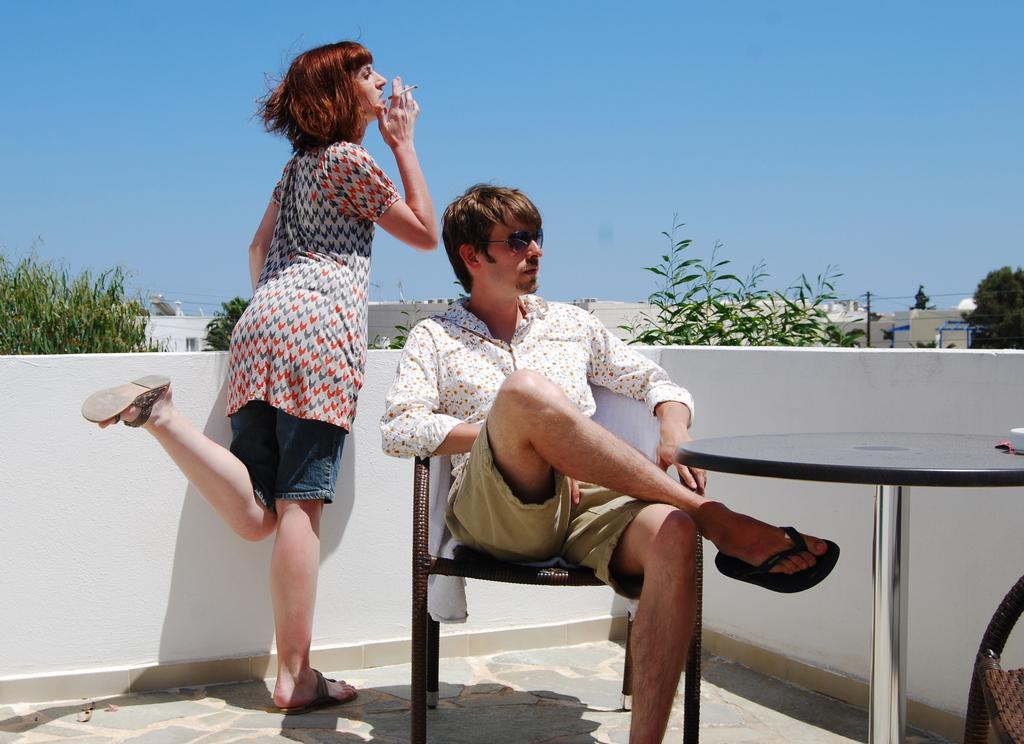In one or two sentences, can you explain what this image depicts? This picture shows a woman standing near the cement railing and smoking. There is a man sitting in the chair in front a table. In the background, there are some plants, trees and a sky here. 